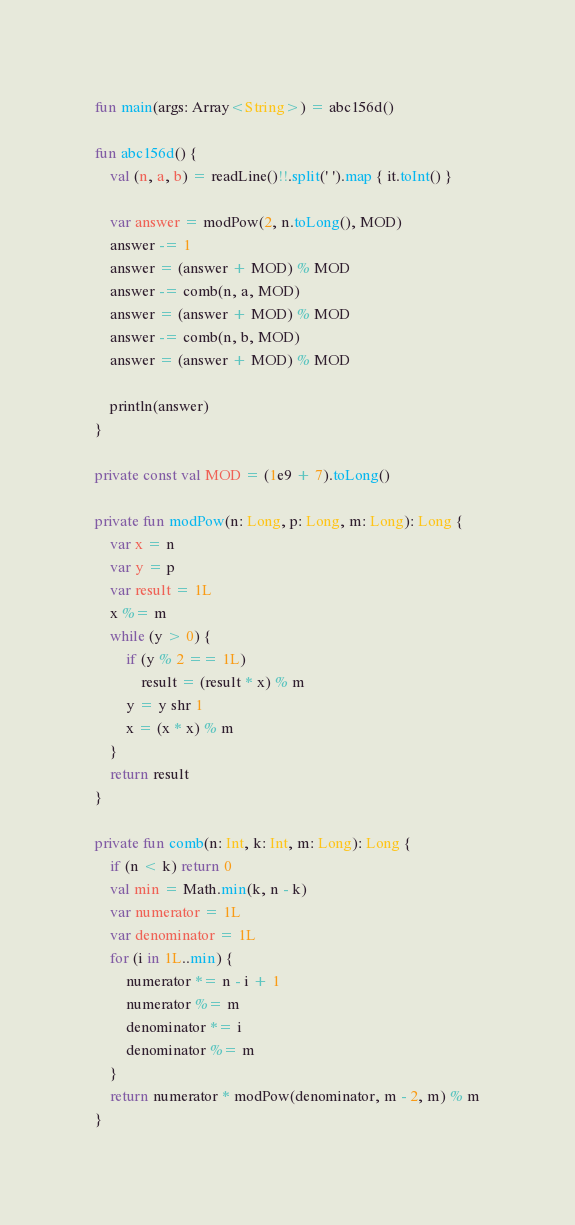<code> <loc_0><loc_0><loc_500><loc_500><_Kotlin_>fun main(args: Array<String>) = abc156d()

fun abc156d() {
    val (n, a, b) = readLine()!!.split(' ').map { it.toInt() }

    var answer = modPow(2, n.toLong(), MOD)
    answer -= 1
    answer = (answer + MOD) % MOD
    answer -= comb(n, a, MOD)
    answer = (answer + MOD) % MOD
    answer -= comb(n, b, MOD)
    answer = (answer + MOD) % MOD

    println(answer)
}

private const val MOD = (1e9 + 7).toLong()

private fun modPow(n: Long, p: Long, m: Long): Long {
    var x = n
    var y = p
    var result = 1L
    x %= m
    while (y > 0) {
        if (y % 2 == 1L)
            result = (result * x) % m
        y = y shr 1
        x = (x * x) % m
    }
    return result
}

private fun comb(n: Int, k: Int, m: Long): Long {
    if (n < k) return 0
    val min = Math.min(k, n - k)
    var numerator = 1L
    var denominator = 1L
    for (i in 1L..min) {
        numerator *= n - i + 1
        numerator %= m
        denominator *= i
        denominator %= m
    }
    return numerator * modPow(denominator, m - 2, m) % m
}
</code> 